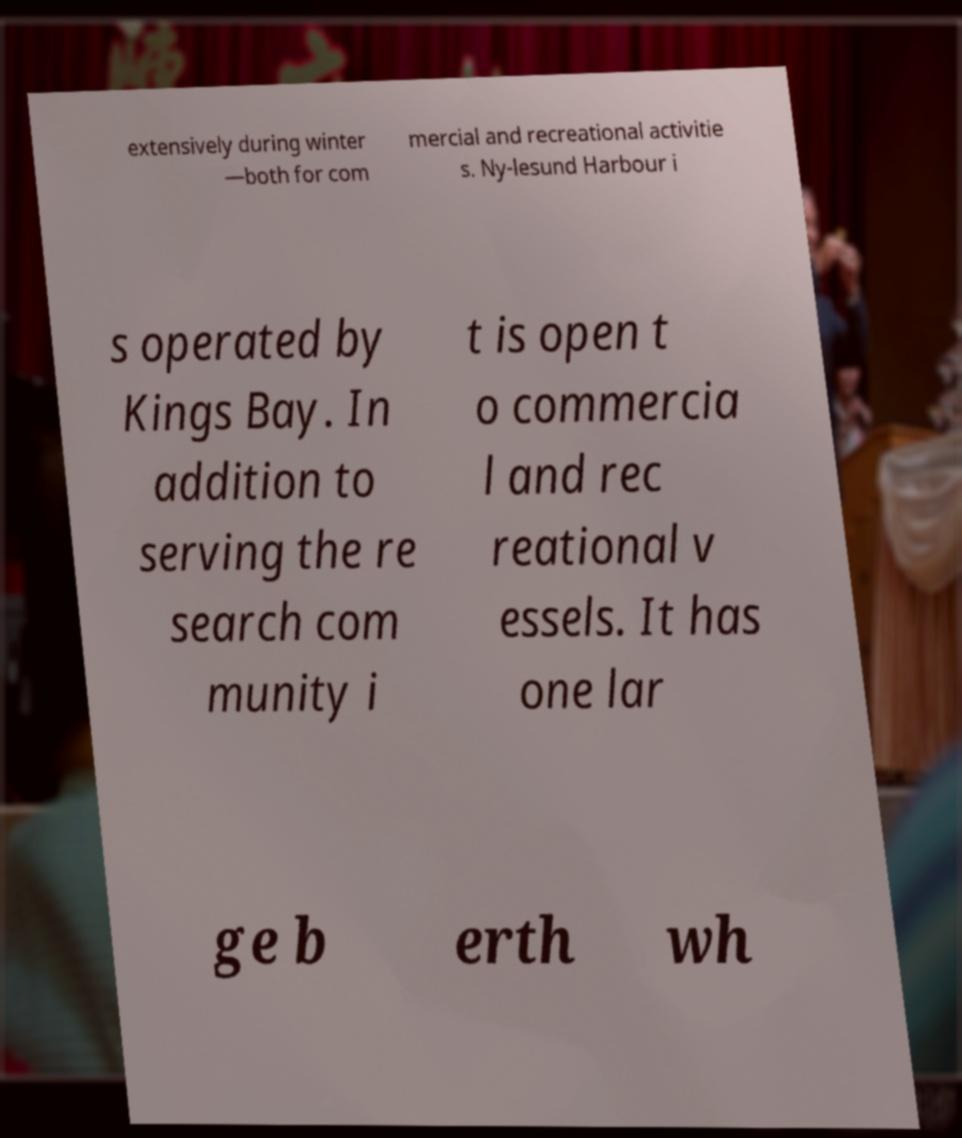Could you extract and type out the text from this image? extensively during winter —both for com mercial and recreational activitie s. Ny-lesund Harbour i s operated by Kings Bay. In addition to serving the re search com munity i t is open t o commercia l and rec reational v essels. It has one lar ge b erth wh 